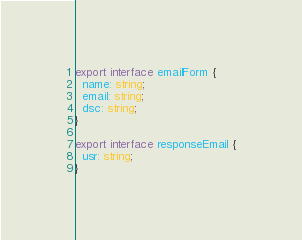<code> <loc_0><loc_0><loc_500><loc_500><_TypeScript_>export interface emailForm {
  name: string;
  email: string;
  dsc: string;
}

export interface responseEmail {
  usr: string;
}
</code> 